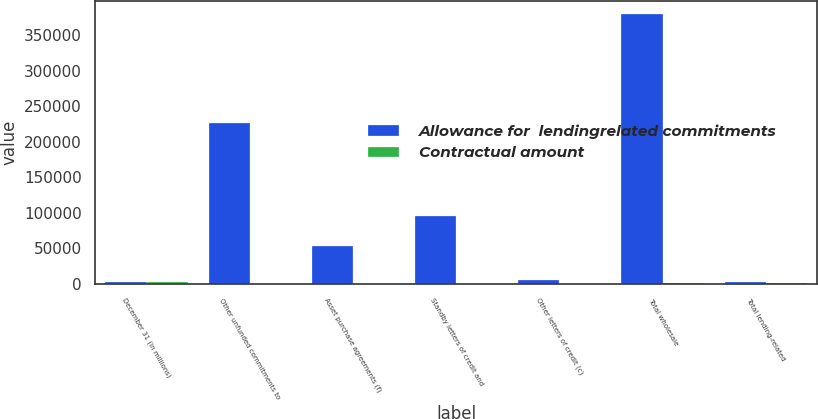<chart> <loc_0><loc_0><loc_500><loc_500><stacked_bar_chart><ecel><fcel>December 31 (in millions)<fcel>Other unfunded commitments to<fcel>Asset purchase agreements (f)<fcel>Standby letters of credit and<fcel>Other letters of credit (c)<fcel>Total wholesale<fcel>Total lending-related<nl><fcel>Allowance for  lendingrelated commitments<fcel>2008<fcel>225863<fcel>53729<fcel>95352<fcel>4927<fcel>379871<fcel>2008<nl><fcel>Contractual amount<fcel>2008<fcel>349<fcel>9<fcel>274<fcel>2<fcel>634<fcel>659<nl></chart> 